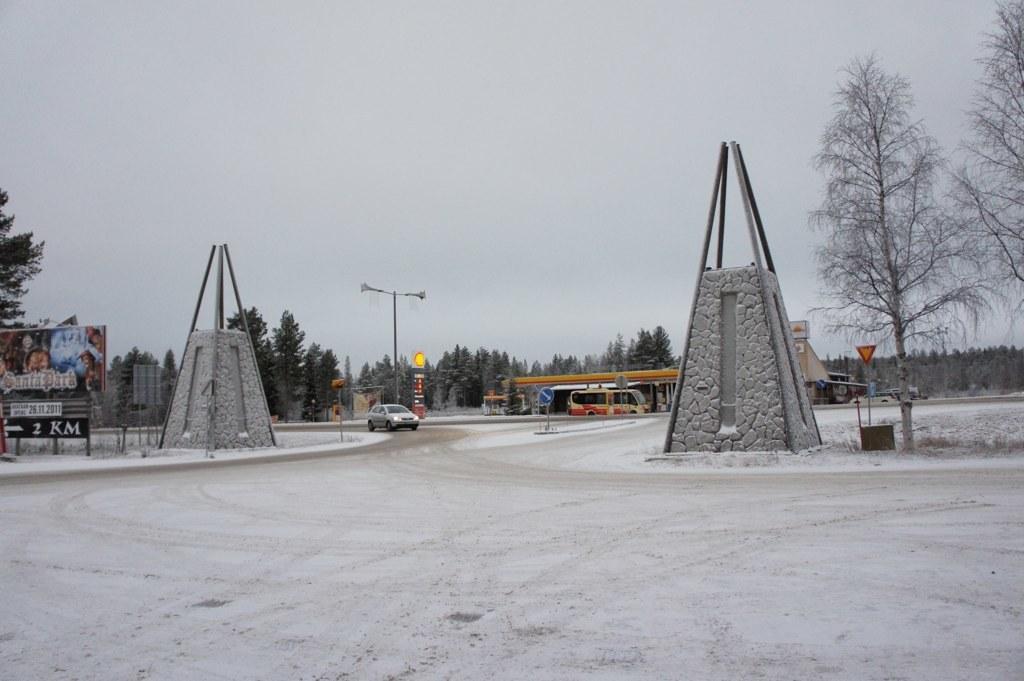Please provide a concise description of this image. To these memorial stones there are rods. Here we can see hoarding, sign board, light pole, vehicles and trees. Background we can see the sky.  